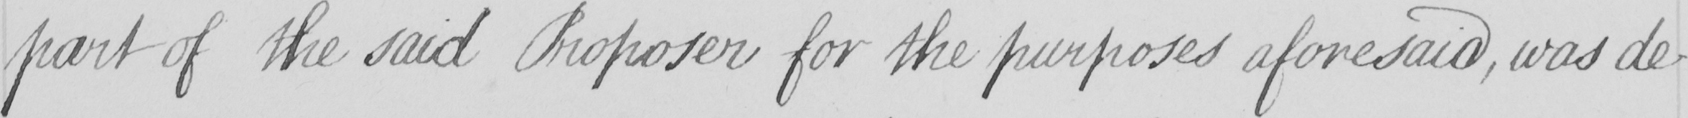What is written in this line of handwriting? part of the said Proposer for the purposes aforesaid , was de- 